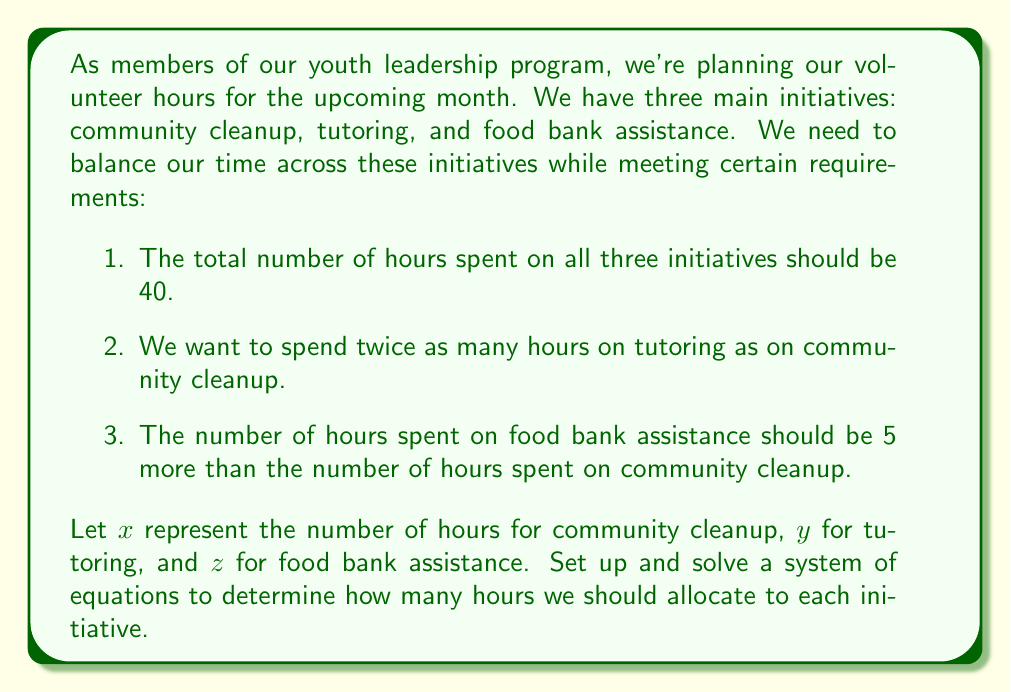Provide a solution to this math problem. Let's approach this step-by-step:

1) First, we'll set up our system of equations based on the given information:

   Equation 1: $x + y + z = 40$ (total hours)
   Equation 2: $y = 2x$ (tutoring is twice community cleanup)
   Equation 3: $z = x + 5$ (food bank is 5 more than community cleanup)

2) Now, let's substitute equations 2 and 3 into equation 1:

   $x + 2x + (x + 5) = 40$

3) Simplify:

   $4x + 5 = 40$

4) Subtract 5 from both sides:

   $4x = 35$

5) Divide both sides by 4:

   $x = 8.75$

6) Now that we know $x$, we can find $y$ and $z$:

   $y = 2x = 2(8.75) = 17.5$
   $z = x + 5 = 8.75 + 5 = 13.75$

7) Let's verify that these values satisfy our original conditions:
   
   Total hours: $8.75 + 17.5 + 13.75 = 40$
   Tutoring is twice community cleanup: $17.5 = 2(8.75)$
   Food bank is 5 more than community cleanup: $13.75 = 8.75 + 5$

All conditions are satisfied.
Answer: Community cleanup: $8.75$ hours
Tutoring: $17.5$ hours
Food bank assistance: $13.75$ hours 